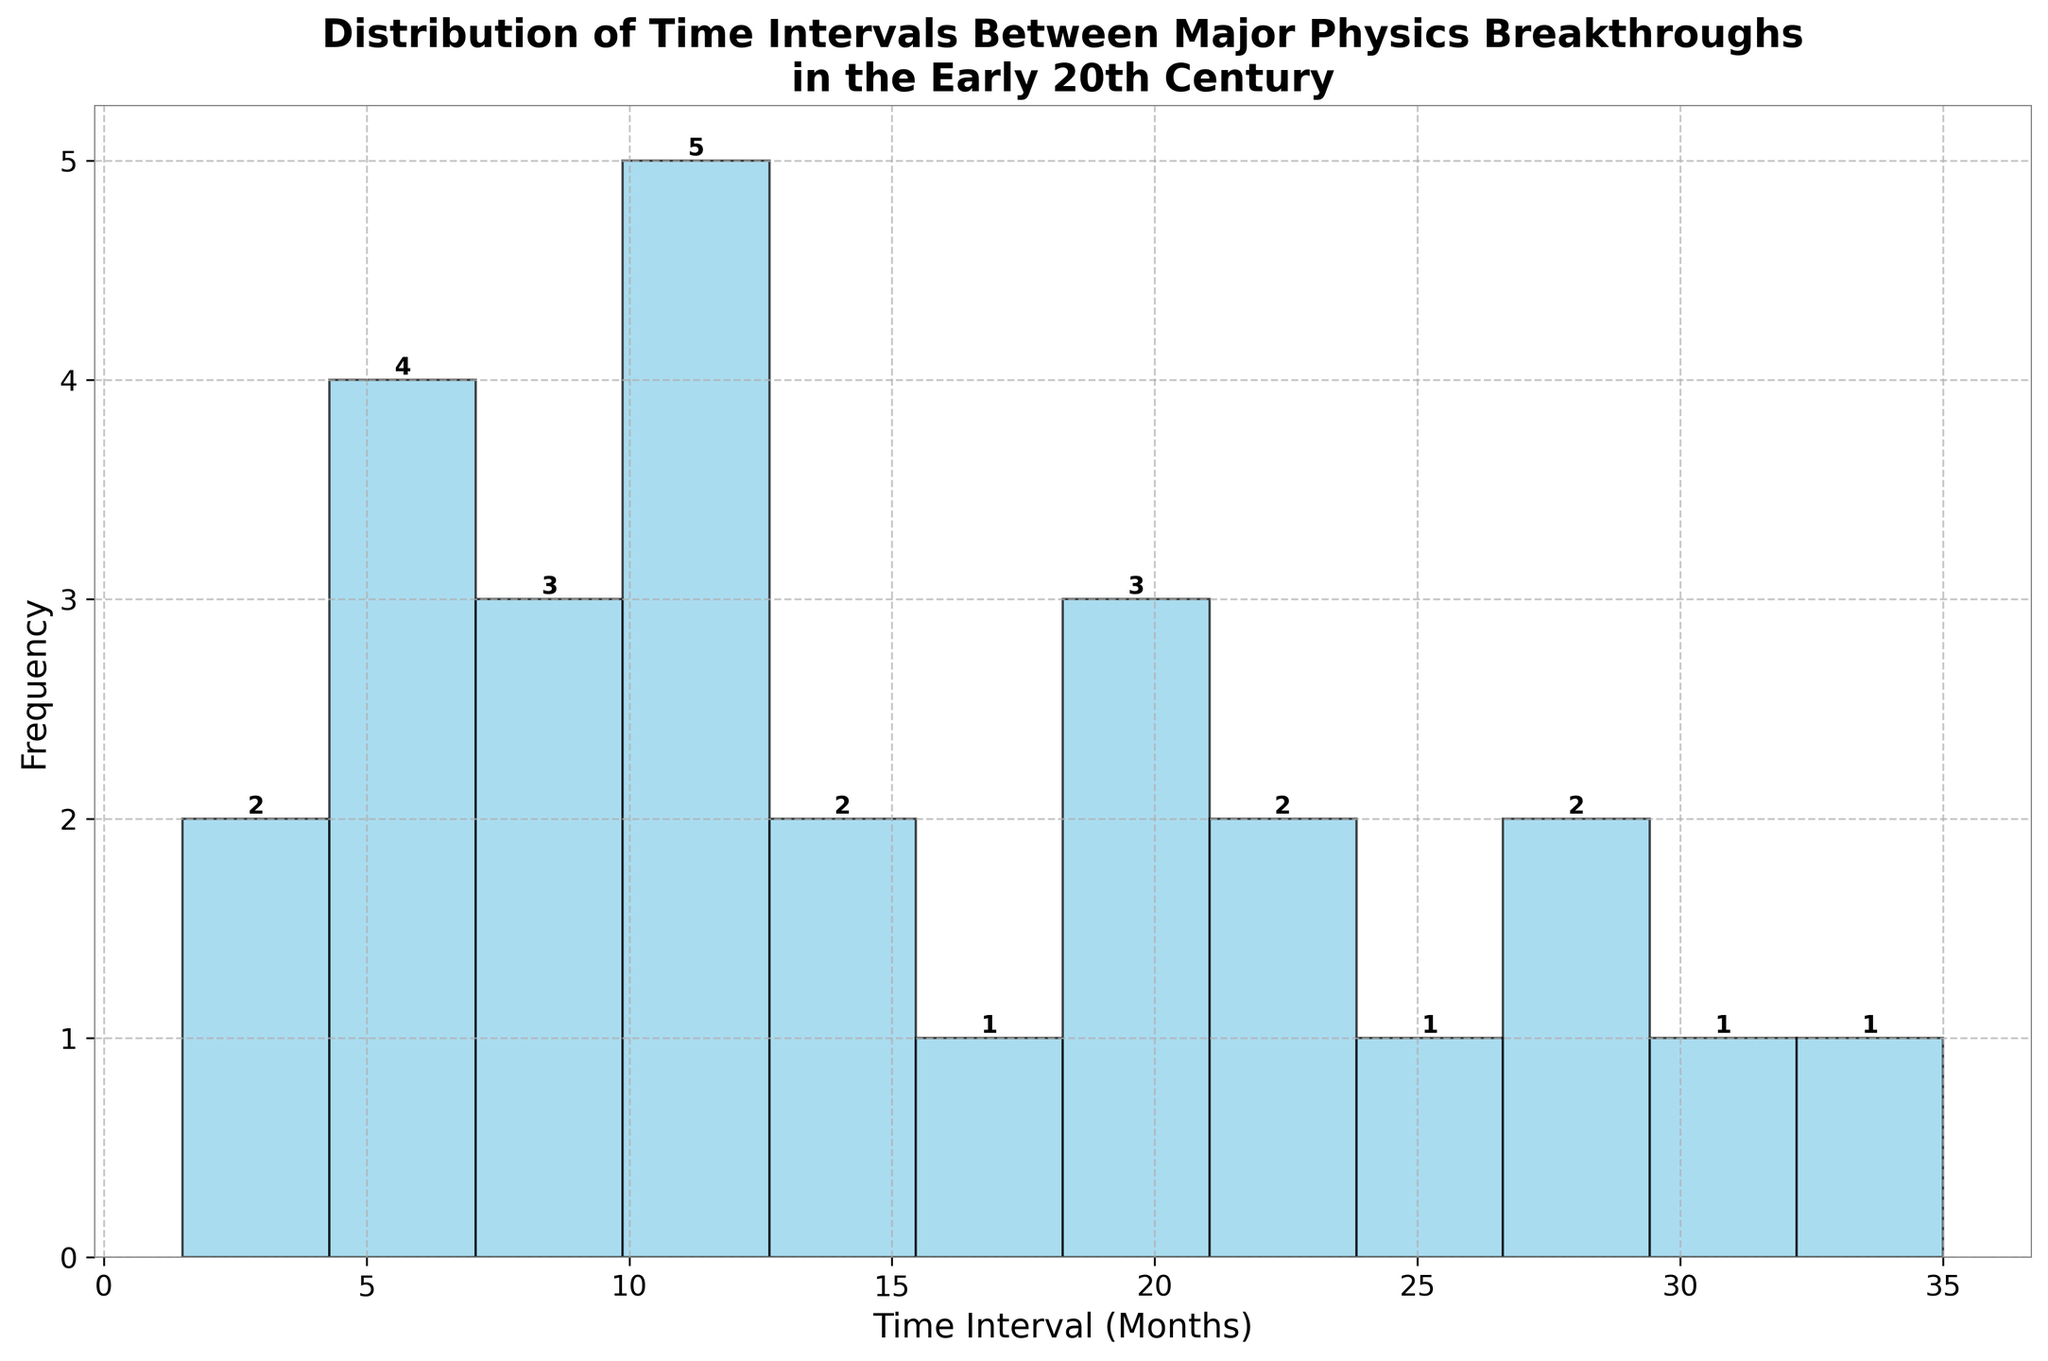What is the title of the histogram? The title is written at the top of the histogram. It reads "Distribution of Time Intervals Between Major Physics Breakthroughs\nin the Early 20th Century"
Answer: Distribution of Time Intervals Between Major Physics Breakthroughs in the Early 20th Century How many time intervals have the highest frequency? To find the time intervals with the highest frequency, observe the height of each bar. The tallest bars represent the highest frequency. There is one interval with the highest bar.
Answer: 1 What is the frequency of the time interval labeled '10-12 months'? Find the bar for the interval '10-12 months' on the x-axis and look at its height. The frequency number is also written above the bar.
Answer: 5 Which time interval is labeled between 16 and 18 months, and what is its frequency? Find the bar labeled '16-18 months' on the x-axis and check its height. The frequency number is also written above the bar.
Answer: 1 What is the frequency sum of the intervals '19-21 months' and '22-24 months'? Find the bars labeled '19-21 months' and '22-24 months' on the x-axis, and sum their frequencies. The frequencies are 3 and 2 respectively. Therefore, the sum is 3 + 2 = 5
Answer: 5 Which interval has a higher frequency, '7-9 months' or '25-27 months'? Compare the heights of the bars for '7-9 months' and '25-27 months' on the x-axis. The frequency number above each relevant bar indicates that '7-9 months' (3) is higher than '25-27 months' (1).
Answer: 7-9 months What is the combined frequency of all intervals between 0-6 months? Sum the frequencies of the intervals '0-3 months' and '4-6 months' by checking their heights and/or reading the numbers above the bars. The frequencies are 2 and 4 respectively. Therefore, 2 + 4 = 6
Answer: 6 How does the frequency of '13-15 months' compare to '34-36 months'? Check the heights or numbers above the bars for '13-15 months' and '34-36 months'. Both intervals have the same frequency of 1.
Answer: Equal How many intervals have a frequency less than 3? Count the bars with heights or frequency numbers less than 3. They are '0-3 months' (2), '13-15 months' (2), '16-18 months' (1), '22-24 months' (2), '25-27 months' (1), '31-33 months' (1), and '34-36 months' (1). There are seven such intervals.
Answer: 7 